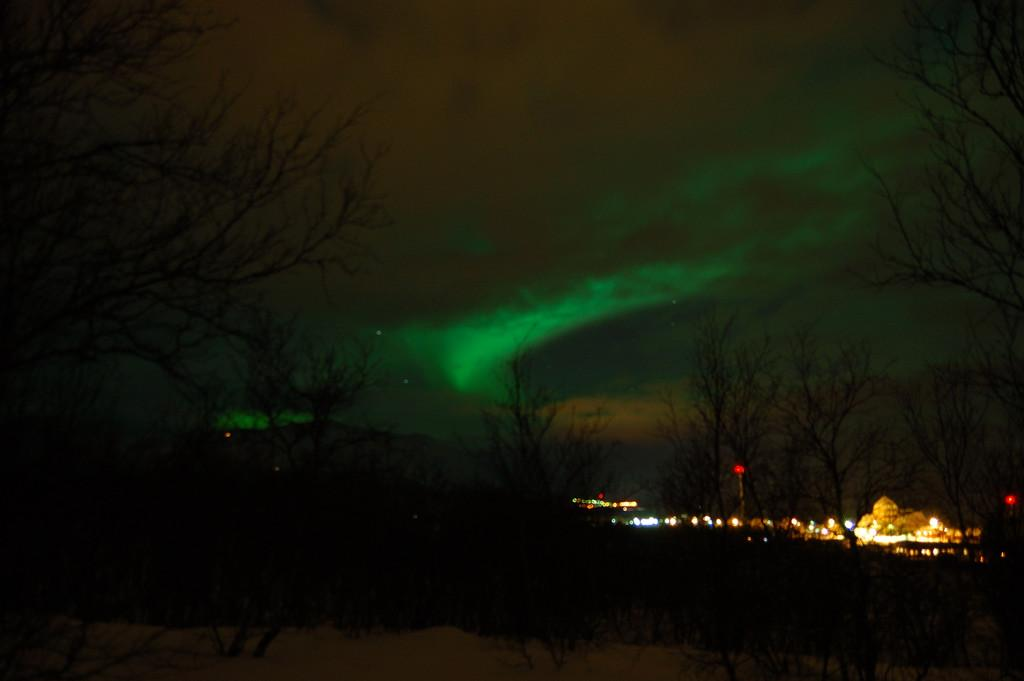What time of day is depicted in the image? The image depicts a night view. What type of terrain can be seen on the ground? There are trees on the sand surface in the image. What structures are visible in the distance? There are buildings visible in the distance. What are the poles with lights used for in the image? The poles with lights are likely used for illumination at night. What can be seen in the background of the image? The sky is visible in the background. What type of milk is being consumed by the giants in the image? There are no giants or milk present in the image. How much muscle can be seen on the creatures in the image? There are no creatures or muscles visible in the image. 